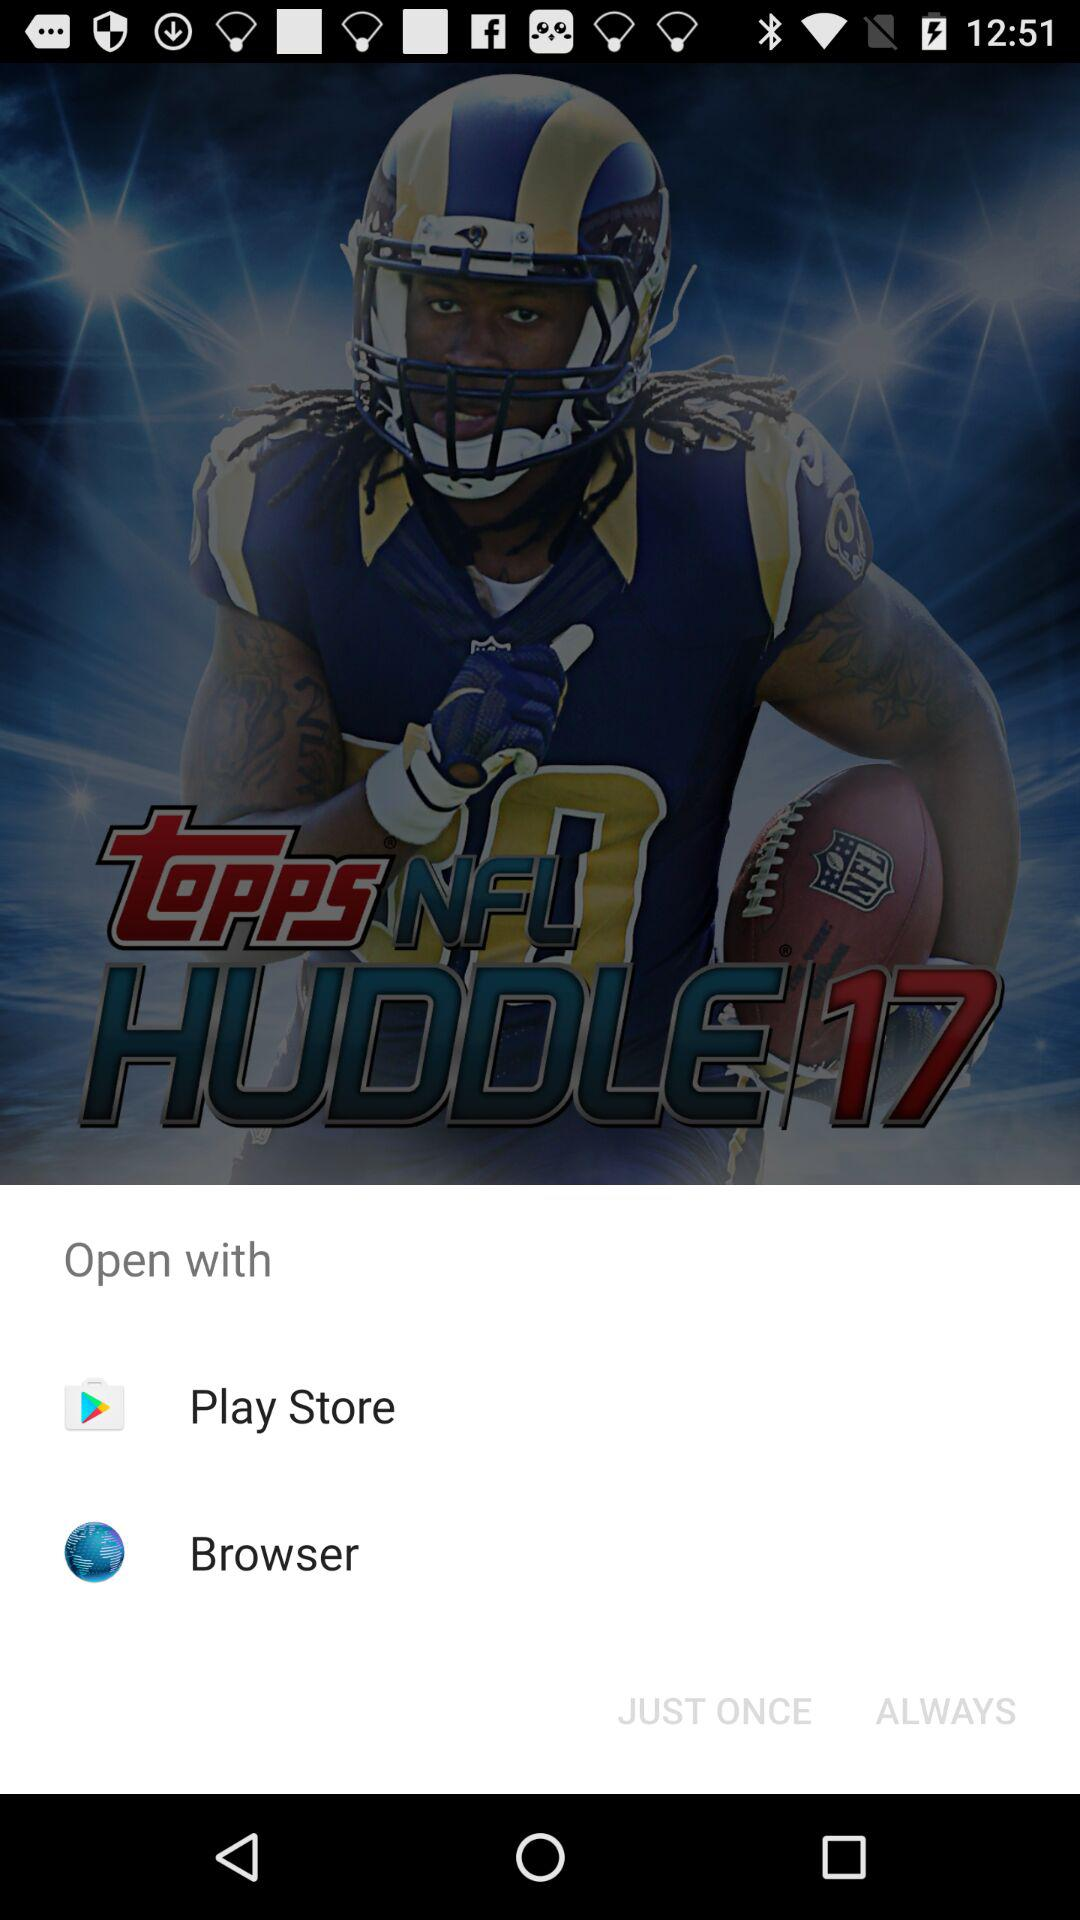What applications are used to open? The applications used to open are "Play Store" and "Browser". 